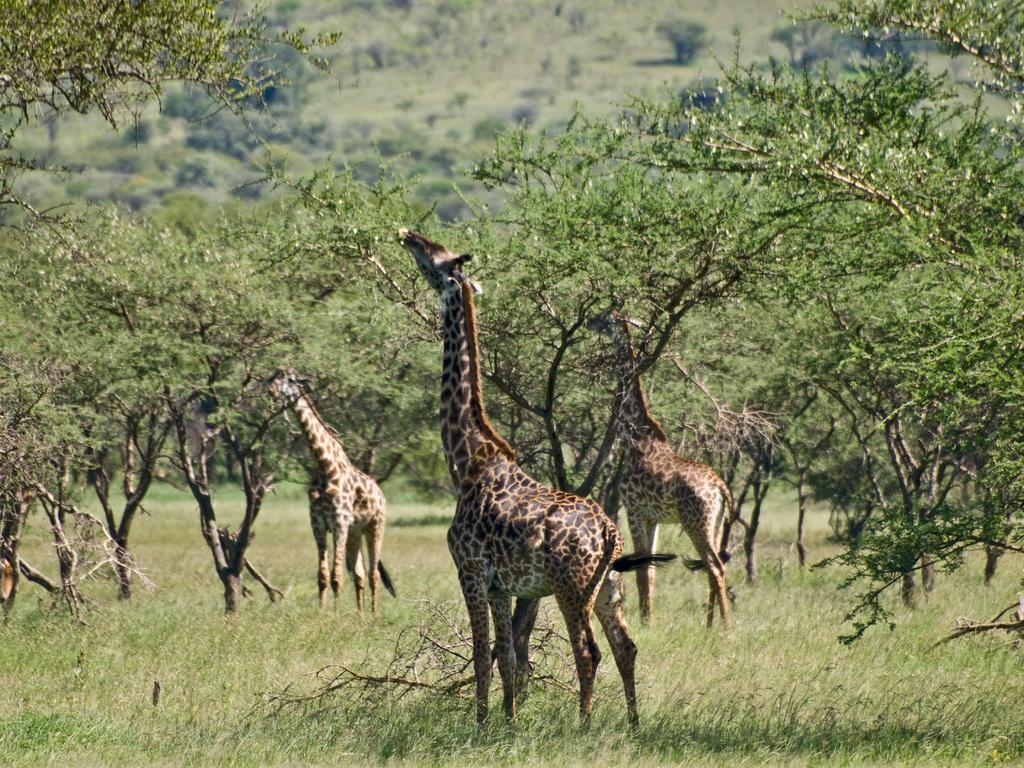How many giraffes are in the image? There are 3 giraffes in the image. What colors are the giraffes? The giraffes are brown and cream in color. What type of vegetation is visible in the image? There is grass visible in the image. What can be seen in the background of the image? There are trees in the background of the image. Who is the creator of the ducks in the image? There are no ducks present in the image, so there is no creator for them. 